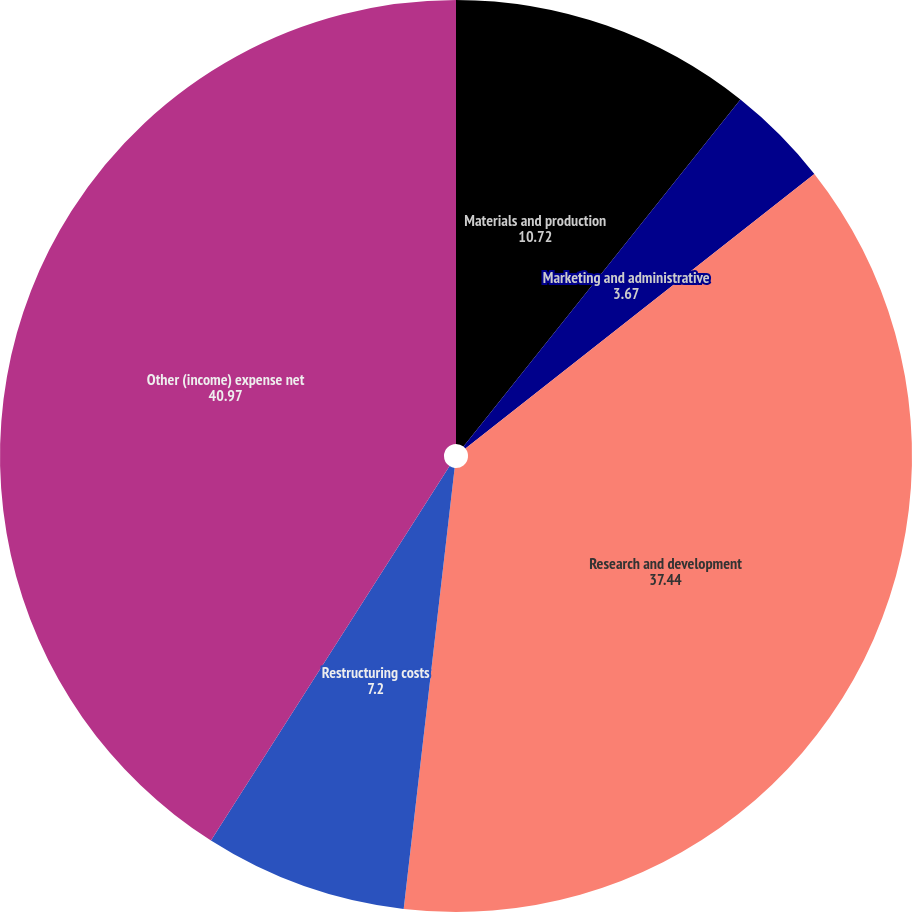Convert chart. <chart><loc_0><loc_0><loc_500><loc_500><pie_chart><fcel>Materials and production<fcel>Marketing and administrative<fcel>Research and development<fcel>Restructuring costs<fcel>Other (income) expense net<nl><fcel>10.72%<fcel>3.67%<fcel>37.44%<fcel>7.2%<fcel>40.97%<nl></chart> 